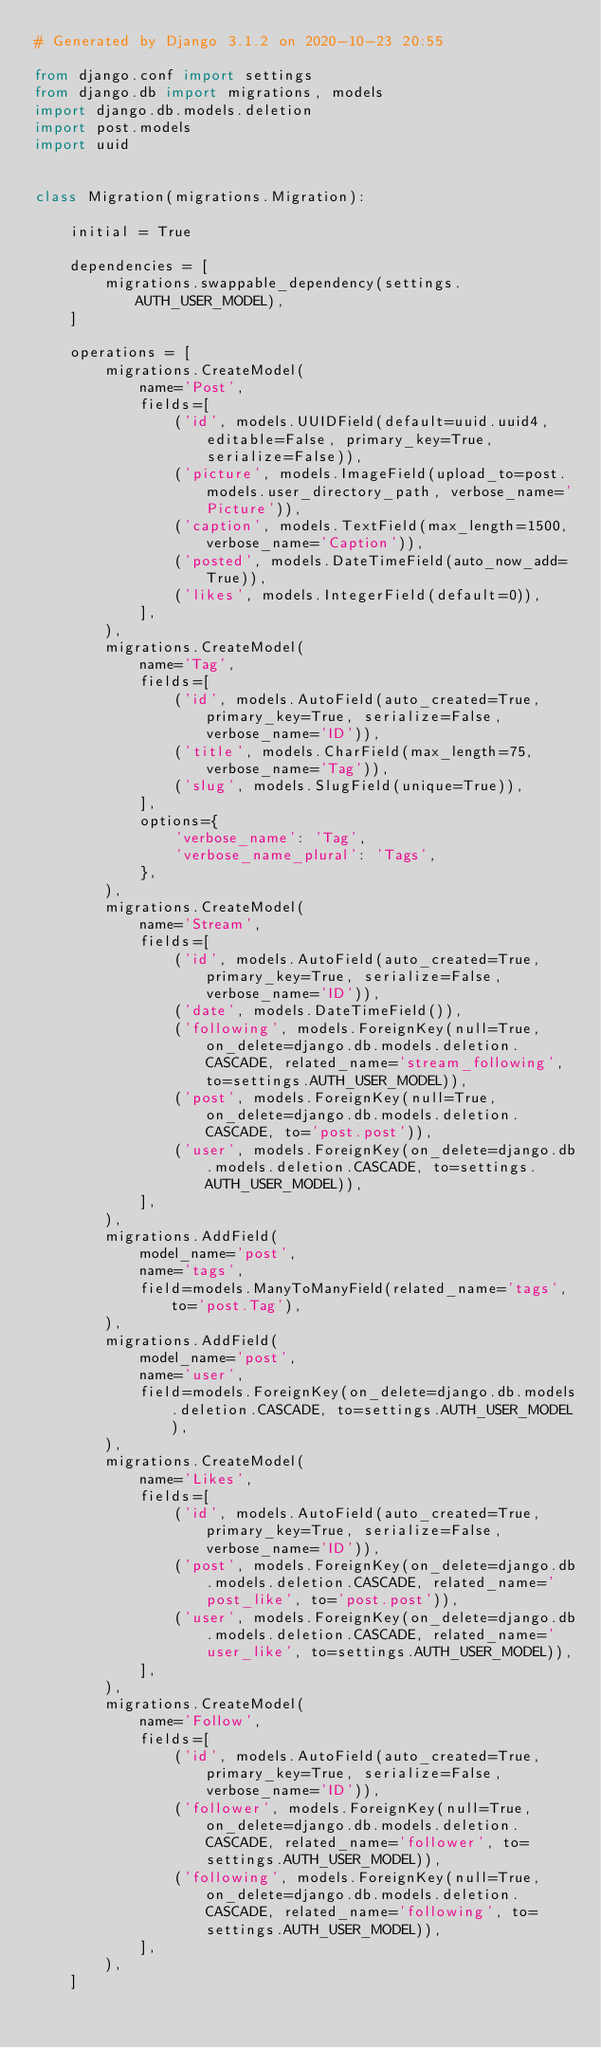<code> <loc_0><loc_0><loc_500><loc_500><_Python_># Generated by Django 3.1.2 on 2020-10-23 20:55

from django.conf import settings
from django.db import migrations, models
import django.db.models.deletion
import post.models
import uuid


class Migration(migrations.Migration):

    initial = True

    dependencies = [
        migrations.swappable_dependency(settings.AUTH_USER_MODEL),
    ]

    operations = [
        migrations.CreateModel(
            name='Post',
            fields=[
                ('id', models.UUIDField(default=uuid.uuid4, editable=False, primary_key=True, serialize=False)),
                ('picture', models.ImageField(upload_to=post.models.user_directory_path, verbose_name='Picture')),
                ('caption', models.TextField(max_length=1500, verbose_name='Caption')),
                ('posted', models.DateTimeField(auto_now_add=True)),
                ('likes', models.IntegerField(default=0)),
            ],
        ),
        migrations.CreateModel(
            name='Tag',
            fields=[
                ('id', models.AutoField(auto_created=True, primary_key=True, serialize=False, verbose_name='ID')),
                ('title', models.CharField(max_length=75, verbose_name='Tag')),
                ('slug', models.SlugField(unique=True)),
            ],
            options={
                'verbose_name': 'Tag',
                'verbose_name_plural': 'Tags',
            },
        ),
        migrations.CreateModel(
            name='Stream',
            fields=[
                ('id', models.AutoField(auto_created=True, primary_key=True, serialize=False, verbose_name='ID')),
                ('date', models.DateTimeField()),
                ('following', models.ForeignKey(null=True, on_delete=django.db.models.deletion.CASCADE, related_name='stream_following', to=settings.AUTH_USER_MODEL)),
                ('post', models.ForeignKey(null=True, on_delete=django.db.models.deletion.CASCADE, to='post.post')),
                ('user', models.ForeignKey(on_delete=django.db.models.deletion.CASCADE, to=settings.AUTH_USER_MODEL)),
            ],
        ),
        migrations.AddField(
            model_name='post',
            name='tags',
            field=models.ManyToManyField(related_name='tags', to='post.Tag'),
        ),
        migrations.AddField(
            model_name='post',
            name='user',
            field=models.ForeignKey(on_delete=django.db.models.deletion.CASCADE, to=settings.AUTH_USER_MODEL),
        ),
        migrations.CreateModel(
            name='Likes',
            fields=[
                ('id', models.AutoField(auto_created=True, primary_key=True, serialize=False, verbose_name='ID')),
                ('post', models.ForeignKey(on_delete=django.db.models.deletion.CASCADE, related_name='post_like', to='post.post')),
                ('user', models.ForeignKey(on_delete=django.db.models.deletion.CASCADE, related_name='user_like', to=settings.AUTH_USER_MODEL)),
            ],
        ),
        migrations.CreateModel(
            name='Follow',
            fields=[
                ('id', models.AutoField(auto_created=True, primary_key=True, serialize=False, verbose_name='ID')),
                ('follower', models.ForeignKey(null=True, on_delete=django.db.models.deletion.CASCADE, related_name='follower', to=settings.AUTH_USER_MODEL)),
                ('following', models.ForeignKey(null=True, on_delete=django.db.models.deletion.CASCADE, related_name='following', to=settings.AUTH_USER_MODEL)),
            ],
        ),
    ]
</code> 